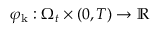<formula> <loc_0><loc_0><loc_500><loc_500>\varphi _ { k } \colon \Omega _ { t } \times ( 0 , T ) \to \mathbb { R }</formula> 